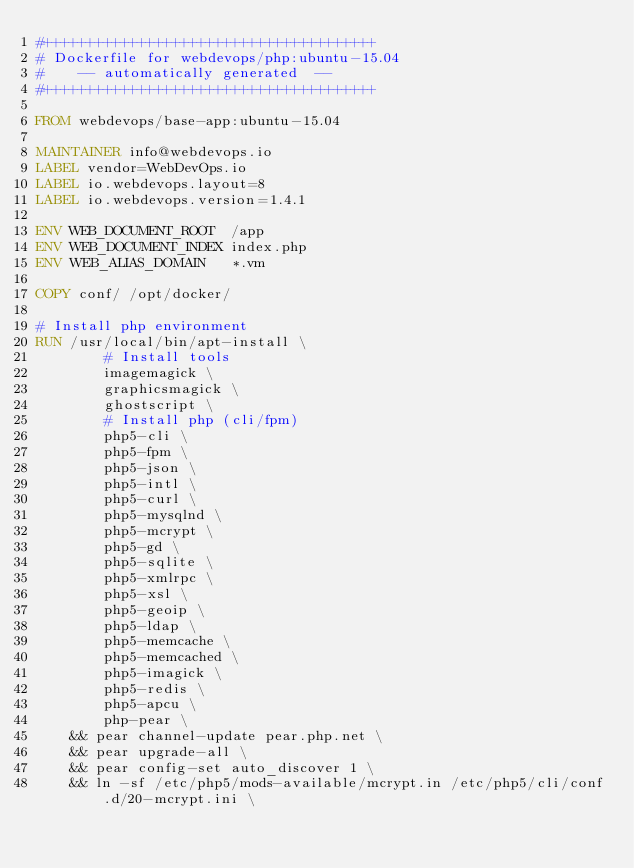Convert code to text. <code><loc_0><loc_0><loc_500><loc_500><_Dockerfile_>#+++++++++++++++++++++++++++++++++++++++
# Dockerfile for webdevops/php:ubuntu-15.04
#    -- automatically generated  --
#+++++++++++++++++++++++++++++++++++++++

FROM webdevops/base-app:ubuntu-15.04

MAINTAINER info@webdevops.io
LABEL vendor=WebDevOps.io
LABEL io.webdevops.layout=8
LABEL io.webdevops.version=1.4.1

ENV WEB_DOCUMENT_ROOT  /app
ENV WEB_DOCUMENT_INDEX index.php
ENV WEB_ALIAS_DOMAIN   *.vm

COPY conf/ /opt/docker/

# Install php environment
RUN /usr/local/bin/apt-install \
        # Install tools
        imagemagick \
        graphicsmagick \
        ghostscript \
        # Install php (cli/fpm)
        php5-cli \
        php5-fpm \
        php5-json \
        php5-intl \
        php5-curl \
        php5-mysqlnd \
        php5-mcrypt \
        php5-gd \
        php5-sqlite \
        php5-xmlrpc \
        php5-xsl \
        php5-geoip \
        php5-ldap \
        php5-memcache \
        php5-memcached \
        php5-imagick \
        php5-redis \
        php5-apcu \
        php-pear \
    && pear channel-update pear.php.net \
    && pear upgrade-all \
    && pear config-set auto_discover 1 \
    && ln -sf /etc/php5/mods-available/mcrypt.in /etc/php5/cli/conf.d/20-mcrypt.ini \</code> 